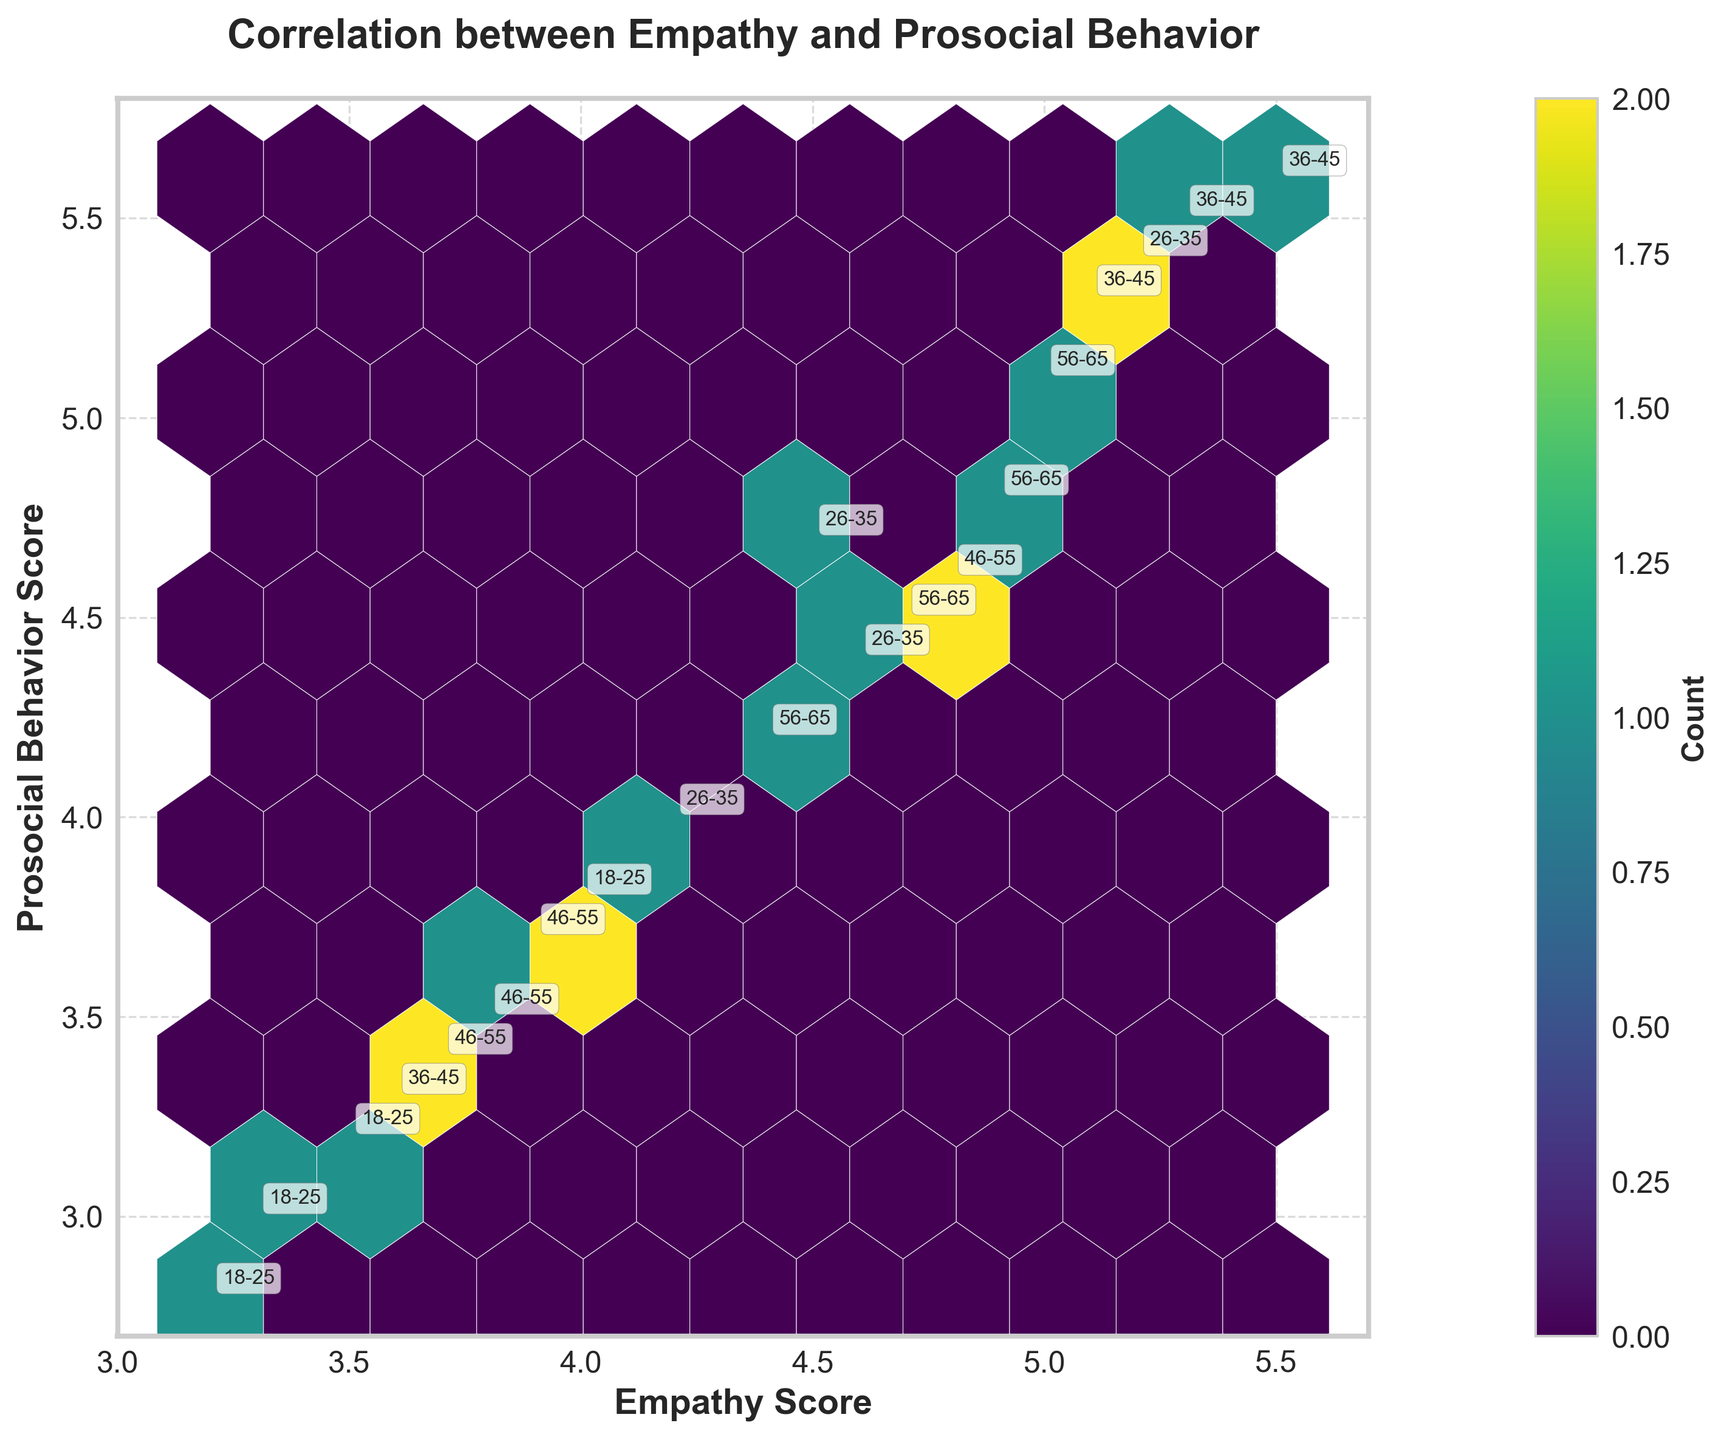What's the title of the plot? The title is prominently displayed at the top of the plot, indicating the main focus of the visualization.
Answer: Correlation between Empathy and Prosocial Behavior What do the x and y axes represent? The x-axis represents the 'Empathy Score', while the y-axis represents the 'Prosocial Behavior Score'. These are labeled on the respective axes.
Answer: Empathy Score and Prosocial Behavior Score What is the colorbar representing? The colorbar indicates the count or the number of data points within each hexagonal bin in the plot, helping to understand the density of data points.
Answer: Count Which age group has the highest density of overlapping data points? This can be determined by observing which age group annotations coincide with the darkest hexagonal bins on the plot.
Answer: 26-35, 36-45, 56-65 Is there a positive correlation between empathy scores and prosocial behavior scores? By observing the trend direction of data points clustering in the plot, a positive correlation is indicated if higher empathy scores align with higher prosocial behavior scores.
Answer: Yes Which gender and education level combination shows the highest empathy and prosocial behavior scores? Look for the annotation labels in the hexagon with highest values on both axes, which indicate gender and education level.
Answer: Male, Master's How does the prosocial behavior score change as the empathy score changes from 3.2 to 5.5? Observe the general trend in the plot from empathy score 3.2 to 5.5 and check the corresponding prosocial behavior score changes.
Answer: Increases Which age group consistently shows higher prosocial behavior scores? Check the annotations for age groups and their corresponding positions on the y-axis, focusing on those with consistently high y-values.
Answer: 36-45 and 56-65 Is there a noticeable difference in the hexbin density between different gender groups? Compare the densities of hexagonal bins, taking note of any patterns or significant differences between male and female groups.
Answer: Yes Among the age groups 18-25 and 56-65, which one has higher empathy scores on average? Check the annotations of these specific age groups and their positions on the x-axis to compare their average empathy scores visually.
Answer: 56-65 